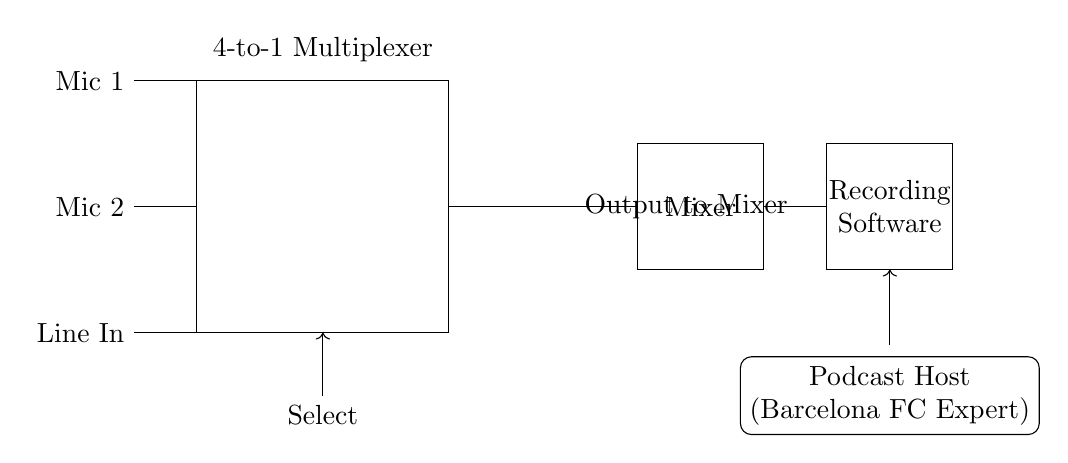What is the main component shown in the circuit diagram? The main component is a 4-to-1 multiplexer, which is designed to select one of multiple audio inputs based on select lines.
Answer: 4-to-1 multiplexer How many audio inputs does the multiplexer have? The multiplexer has three audio inputs: Mic 1, Mic 2, and Line In, as indicated in the diagram with their respective labels.
Answer: Three What is the output of the multiplexer connected to? The output of the multiplexer is connected to a mixer, which will process the selected audio signal for further use in the podcast recording.
Answer: Mixer What is the purpose of the select lines in this circuit? The select lines allow the user to choose which of the audio inputs (Mic 1, Mic 2, or Line In) is sent to the output, effectively controlling the source of the audio signal.
Answer: Choose audio input What does the diagram indicate about the role of the podcast host? The diagram shows that the podcast host is the expert discussing Barcelona FC, indicating their involvement in utilizing the audio setup for communication.
Answer: Podcast host Which direction do the connections from the audio inputs go? The connections from the audio inputs go horizontally to the multiplexer at the left edge; they enter at the left side and connect to the multiplexer.
Answer: Horizontal to multiplexer 